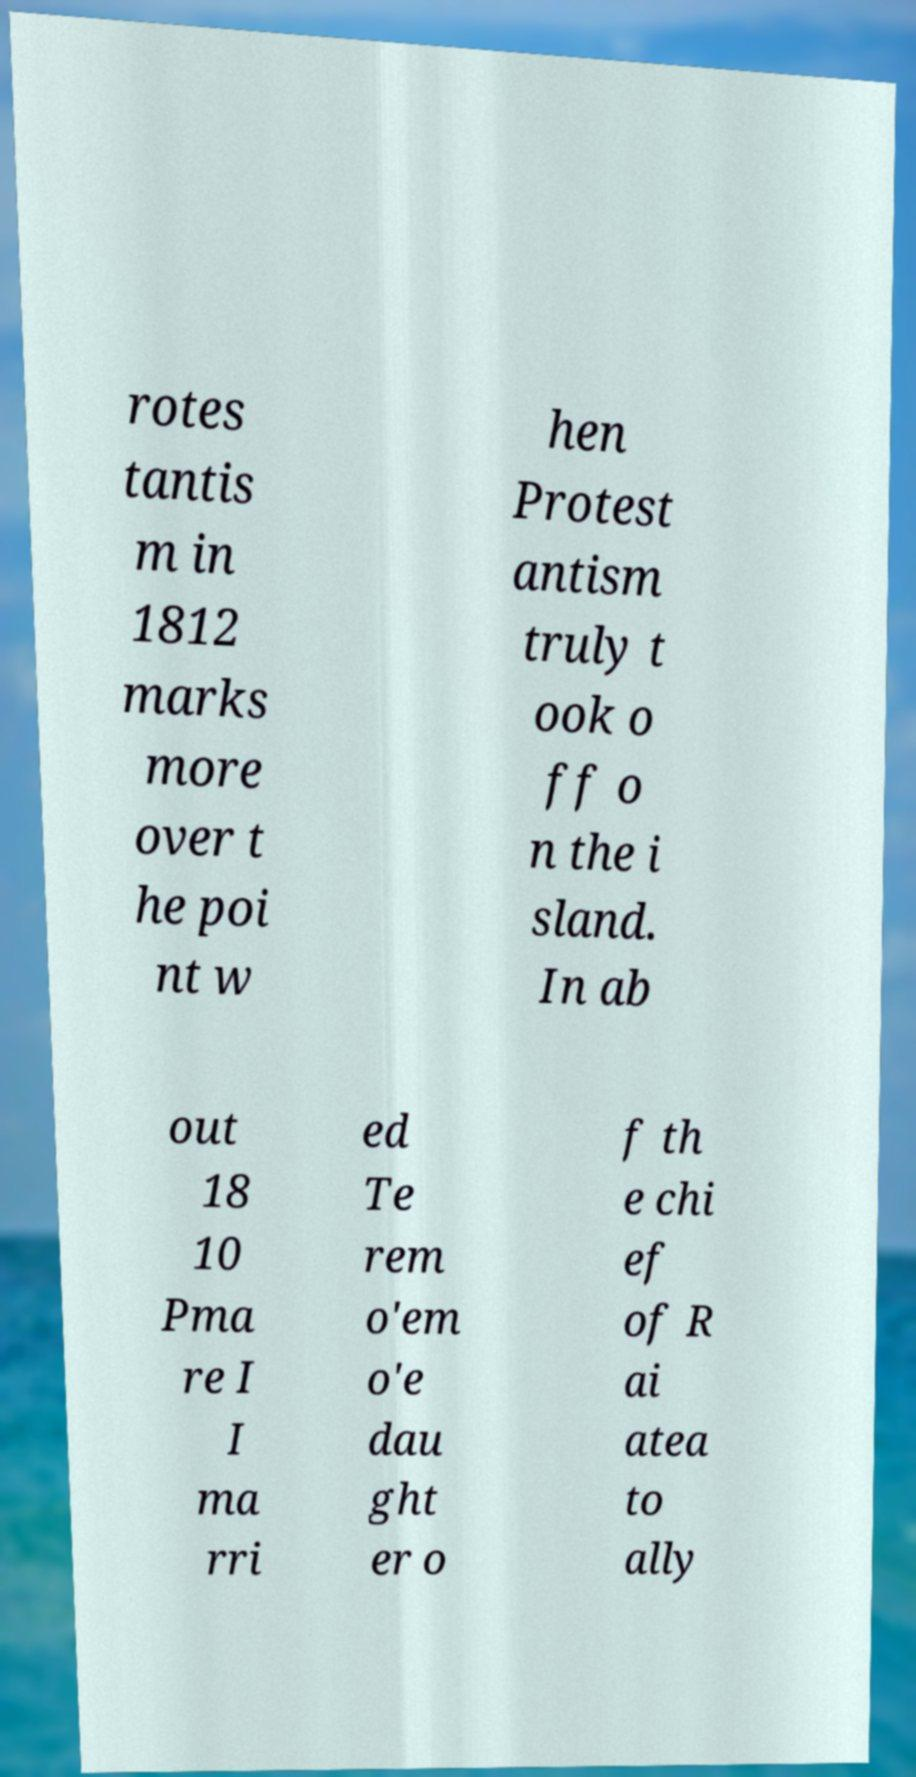Could you assist in decoding the text presented in this image and type it out clearly? rotes tantis m in 1812 marks more over t he poi nt w hen Protest antism truly t ook o ff o n the i sland. In ab out 18 10 Pma re I I ma rri ed Te rem o'em o'e dau ght er o f th e chi ef of R ai atea to ally 